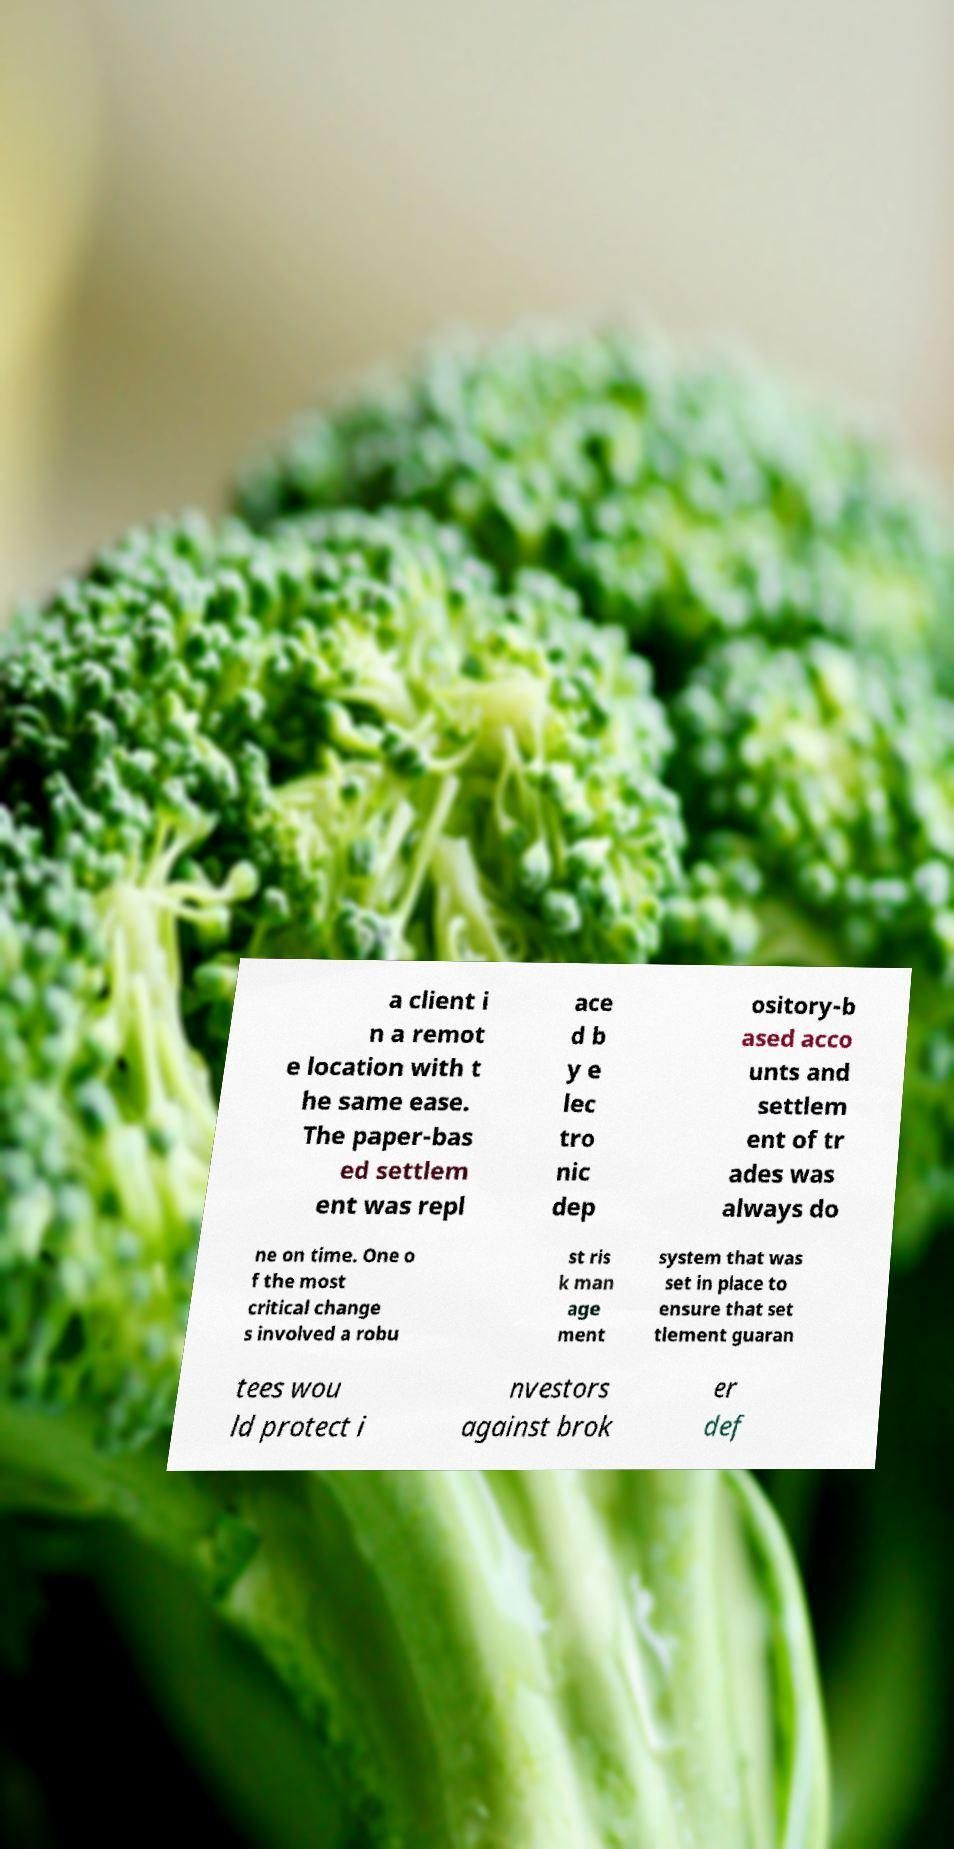For documentation purposes, I need the text within this image transcribed. Could you provide that? a client i n a remot e location with t he same ease. The paper-bas ed settlem ent was repl ace d b y e lec tro nic dep ository-b ased acco unts and settlem ent of tr ades was always do ne on time. One o f the most critical change s involved a robu st ris k man age ment system that was set in place to ensure that set tlement guaran tees wou ld protect i nvestors against brok er def 